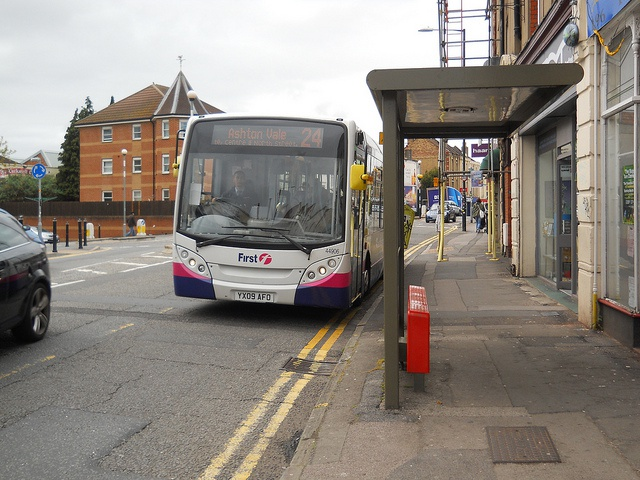Describe the objects in this image and their specific colors. I can see bus in lightgray, gray, darkgray, and black tones, car in lightgray, black, darkgray, and gray tones, people in lightgray, gray, and darkgray tones, car in lightgray, black, gray, and darkgray tones, and people in lightgray, gray, black, and darkgray tones in this image. 